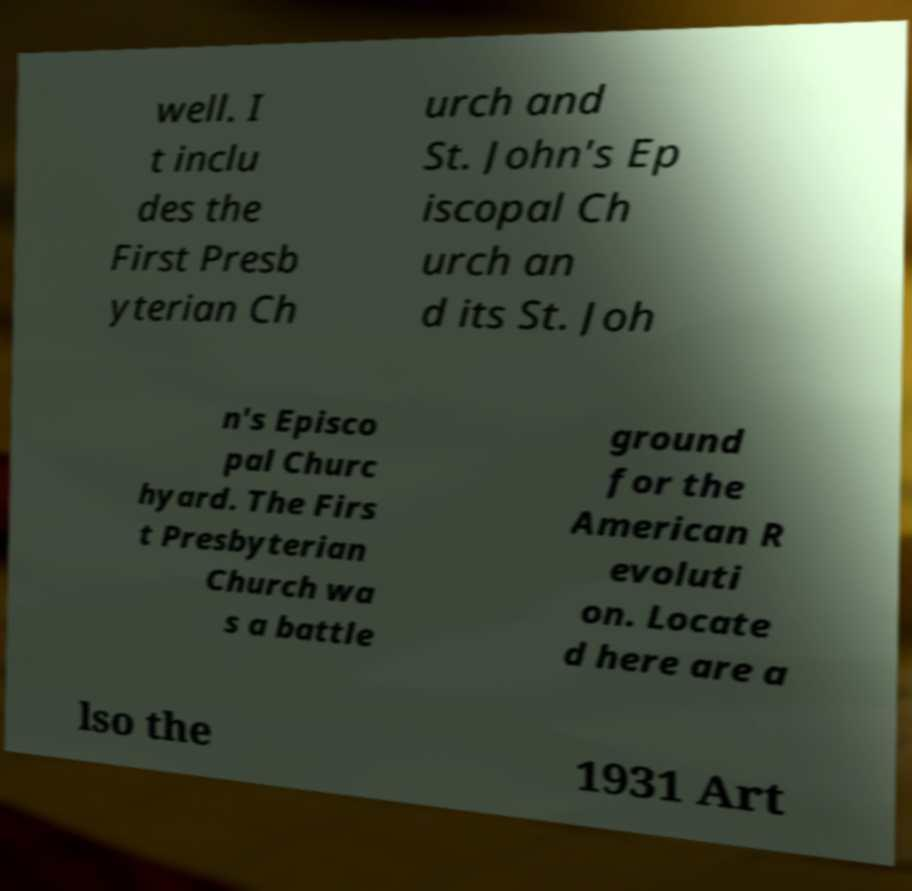Please identify and transcribe the text found in this image. well. I t inclu des the First Presb yterian Ch urch and St. John's Ep iscopal Ch urch an d its St. Joh n's Episco pal Churc hyard. The Firs t Presbyterian Church wa s a battle ground for the American R evoluti on. Locate d here are a lso the 1931 Art 